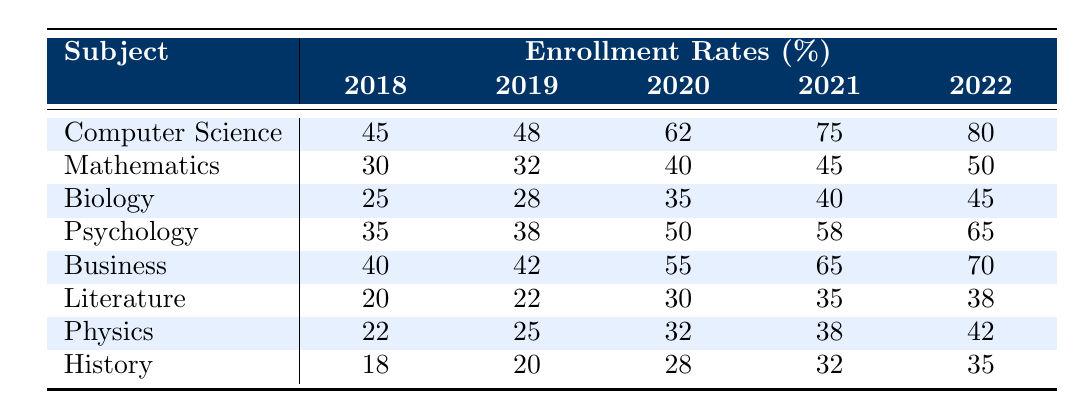What was the enrollment rate for Computer Science in 2022? The table shows the enrollment rates for each subject area by year. For Computer Science, the enrollment rate in 2022 is listed as 80%.
Answer: 80% Which subject area had the highest enrollment rate in 2021? By checking the table, the enrollment rates in 2021 are 75% for Computer Science, 45% for Mathematics, 40% for Biology, 58% for Psychology, 65% for Business, 35% for Literature, 38% for Physics, and 32% for History. The highest value is 75% for Computer Science.
Answer: Computer Science What is the average enrollment rate for Biology over the years 2018 to 2022? The enrollment rates for Biology across the years are 25%, 28%, 35%, 40%, and 45%. Adding these rates gives 25 + 28 + 35 + 40 + 45 = 173. Dividing by 5 gives an average of 173/5 = 34.6%.
Answer: 34.6% Did the enrollment rate for Literature increase every year from 2018 to 2022? Looking at the table, the rates for Literature are 20%, 22%, 30%, 35%, and 38%. Each subsequent year's rate is greater than the previous year, indicating a consistent increase.
Answer: Yes What was the percentage increase in enrollment for Psychology from 2018 to 2022? The enrollment rate for Psychology in 2018 was 35%, and in 2022 it was 65%. To calculate the percentage increase, subtract the 2018 rate from the 2022 rate (65 - 35 = 30), then divide by the 2018 rate (30 / 35) and multiply by 100 to get approximately 85.71%.
Answer: 85.71% Which subject area showed the smallest enrollment rate in 2018? The table lists the enrollment rates in 2018 for all subject areas. They are 45% for Computer Science, 30% for Mathematics, 25% for Biology, 35% for Psychology, 40% for Business, 20% for Literature, 22% for Physics, and 18% for History. The smallest rate is 18% for History.
Answer: History What is the total enrollment rate for all the subjects in 2020? The enrollment rates in 2020 are: 62% for Computer Science, 40% for Mathematics, 35% for Biology, 50% for Psychology, 55% for Business, 30% for Literature, 32% for Physics, and 28% for History. Adding these gives 62 + 40 + 35 + 50 + 55 + 30 + 32 + 28 = 332.
Answer: 332 Which subject had the greatest overall increase in enrollment rates from 2018 to 2022? For each subject, we calculate the difference between the 2022 and 2018 rates: Computer Science (80 - 45 = 35), Mathematics (50 - 30 = 20), Biology (45 - 25 = 20), Psychology (65 - 35 = 30), Business (70 - 40 = 30), Literature (38 - 20 = 18), Physics (42 - 22 = 20), and History (35 - 18 = 17). The largest difference is for Computer Science with 35%.
Answer: Computer Science 